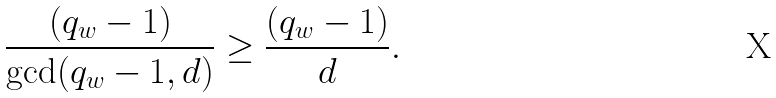Convert formula to latex. <formula><loc_0><loc_0><loc_500><loc_500>\frac { ( q _ { w } - 1 ) } { \gcd ( q _ { w } - 1 , d ) } \geq \frac { ( q _ { w } - 1 ) } { d } .</formula> 